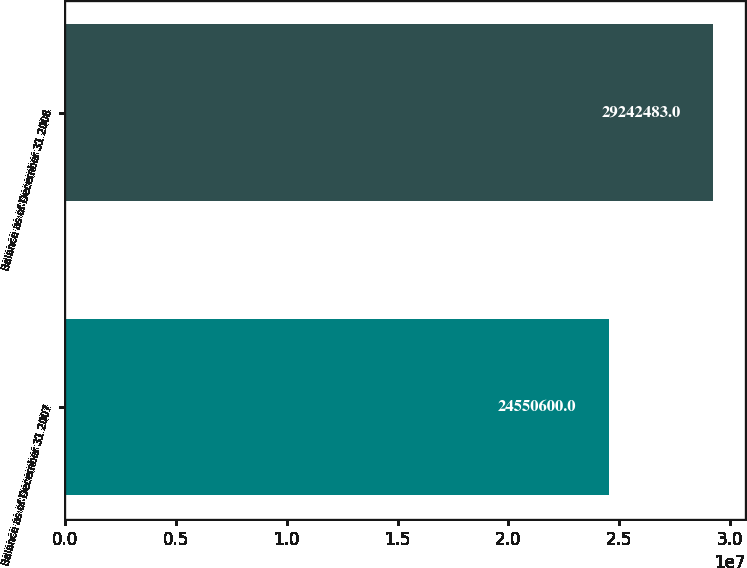Convert chart to OTSL. <chart><loc_0><loc_0><loc_500><loc_500><bar_chart><fcel>Balance as of December 31 2007<fcel>Balance as of December 31 2008<nl><fcel>2.45506e+07<fcel>2.92425e+07<nl></chart> 